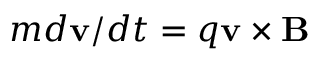<formula> <loc_0><loc_0><loc_500><loc_500>m d v / d t = q v \times B</formula> 